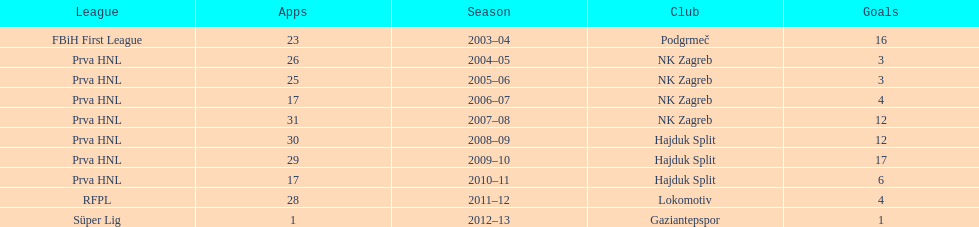Did ibricic score more or less goals in his 3 seasons with hajduk split when compared to his 4 seasons with nk zagreb? More. 